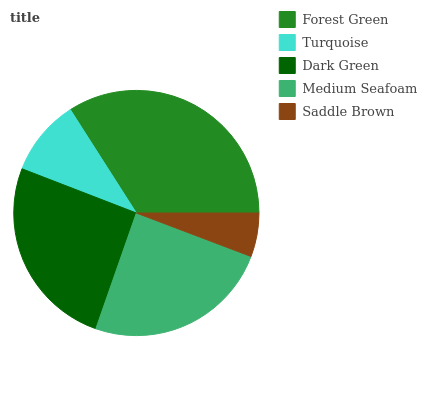Is Saddle Brown the minimum?
Answer yes or no. Yes. Is Forest Green the maximum?
Answer yes or no. Yes. Is Turquoise the minimum?
Answer yes or no. No. Is Turquoise the maximum?
Answer yes or no. No. Is Forest Green greater than Turquoise?
Answer yes or no. Yes. Is Turquoise less than Forest Green?
Answer yes or no. Yes. Is Turquoise greater than Forest Green?
Answer yes or no. No. Is Forest Green less than Turquoise?
Answer yes or no. No. Is Medium Seafoam the high median?
Answer yes or no. Yes. Is Medium Seafoam the low median?
Answer yes or no. Yes. Is Dark Green the high median?
Answer yes or no. No. Is Saddle Brown the low median?
Answer yes or no. No. 